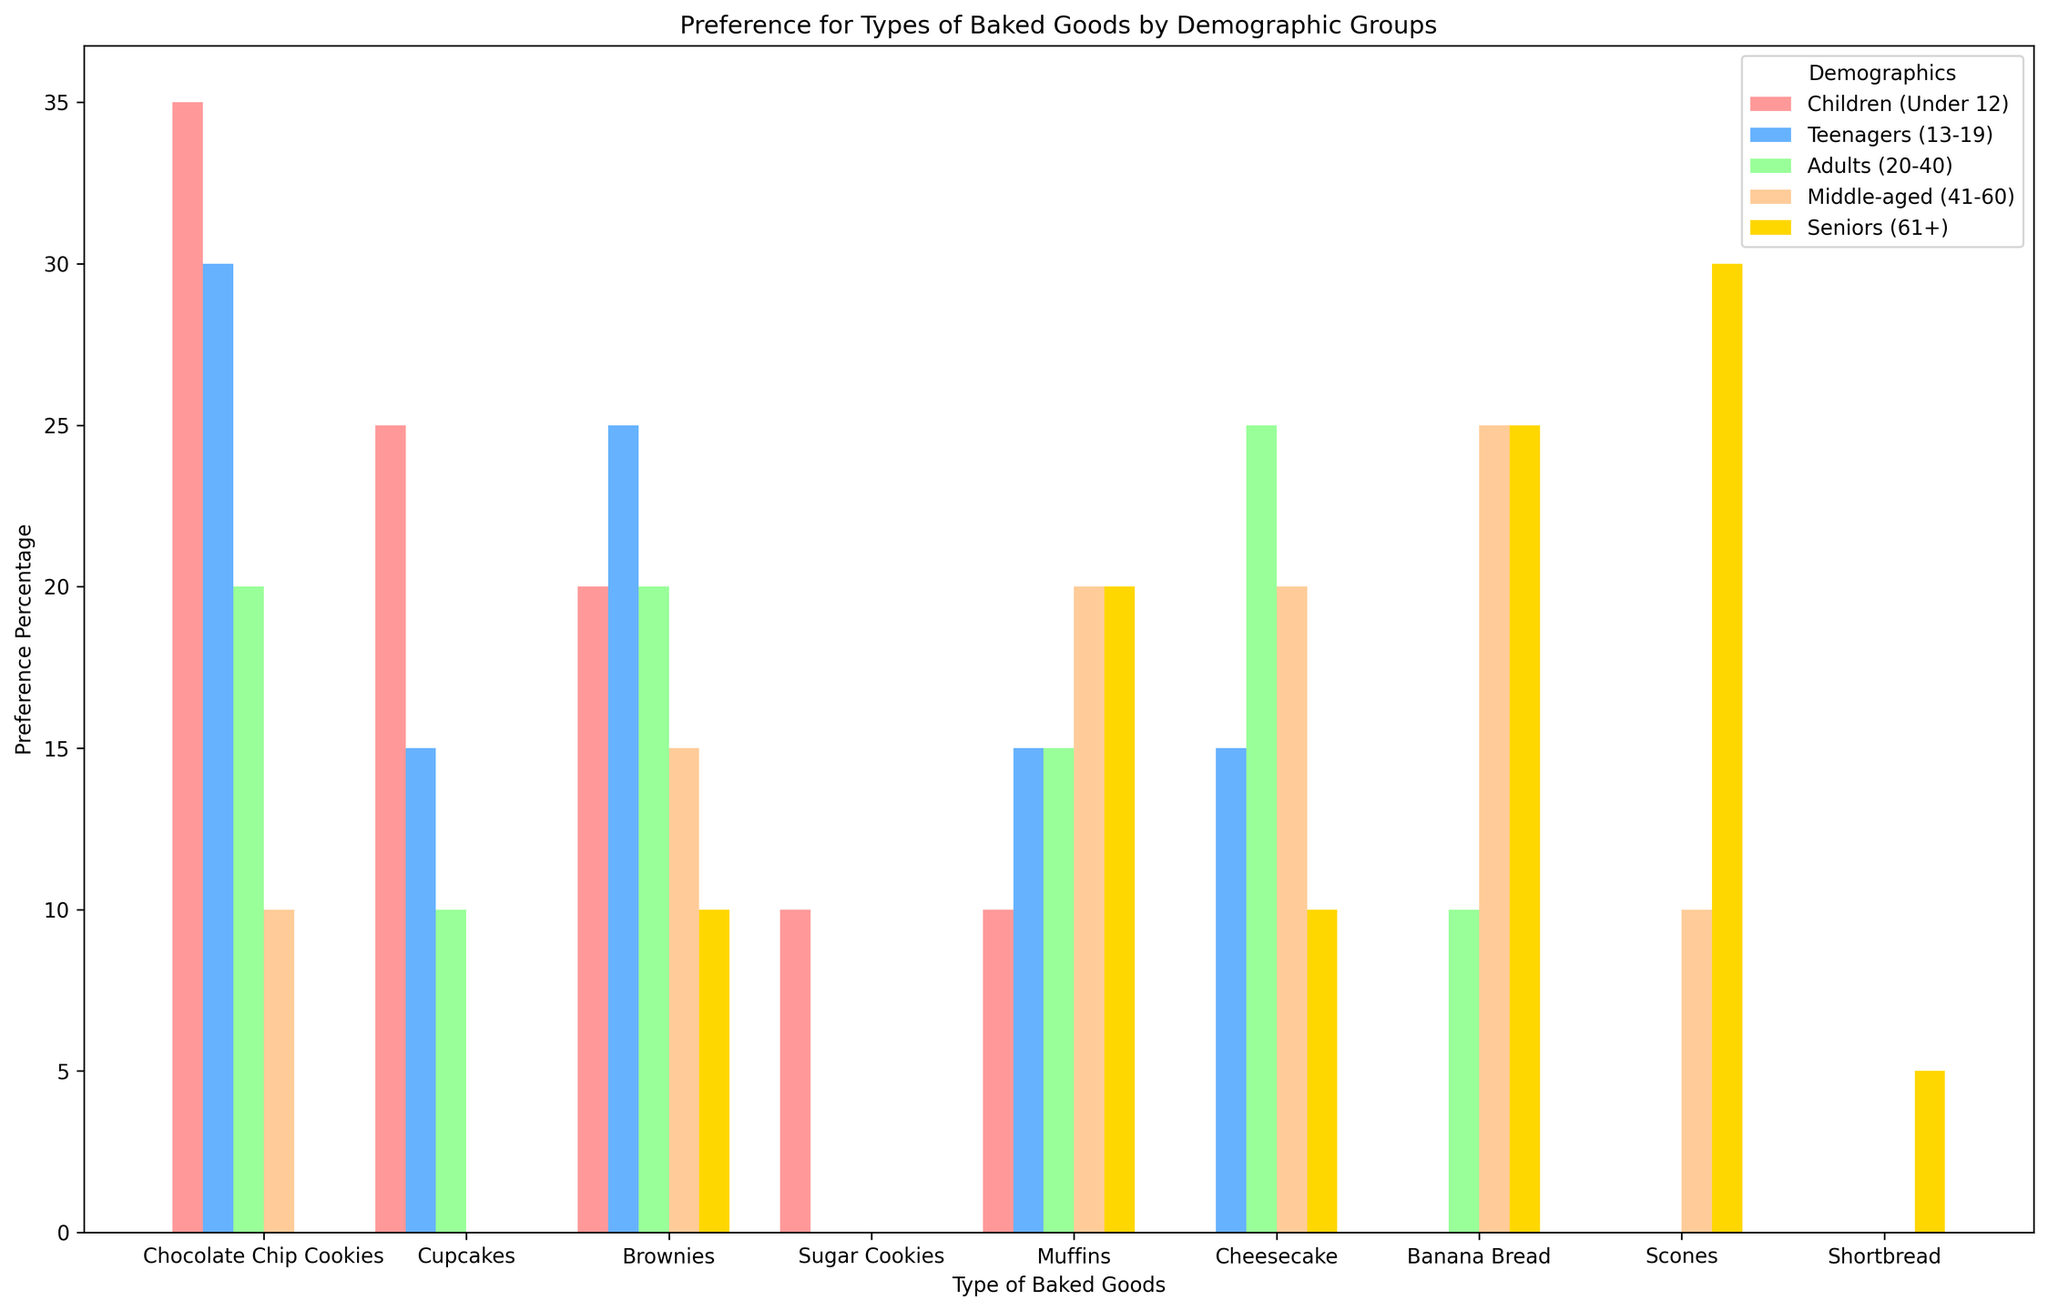What's the most preferred baked good among children? Look at the bar heights for the "Children (Under 12)" category. The tallest bar represents "Chocolate Chip Cookies" with a 35% preference.
Answer: Chocolate Chip Cookies Which demographic group prefers cupcakes the most? Look at the bars for "Cupcakes" across different demographic groups. The highest bar is in the "Children (Under 12)" category at 25%.
Answer: Children (Under 12) Which group shows the highest preference for cheesecake? Examine the bars for "Cheesecake" in different demographics. The highest bar is in the "Adults (20-40)" category at 25%.
Answer: Adults (20-40) How do the preferences for chocolate chip cookies compare between children and teenagers? Compare the heights of the "Chocolate Chip Cookies" bars for "Children (Under 12)" and "Teenagers (13-19)". The children prefer it more (35%) compared to teenagers (30%).
Answer: Children prefer it more Which baked good has the least preference among all demographic groups? Identify the shortest bar in all categories. "Shortbread" among "Seniors (61+)" is the lowest with a 5% preference.
Answer: Shortbread What is the total preference percentage for muffins among all demographic groups? Sum the preference percentages for "Muffins" from all groups: 10% (Children) + 15% (Teenagers) + 15% (Adults) + 20% (Middle-aged) + 20% (Seniors) = 80%.
Answer: 80% Is there any baked good preferred equally by two different demographic groups? Find bars with the same height for any baked good across different demographics. "Cheesecake" is preferred equally by "Teenagers (13-19)" and "Seniors (61+)" at 15%.
Answer: Cheesecake by Teenagers and Seniors What percentage of middle-aged adults prefer scones? Look at the bar height for "Scones" under "Middle-aged (41-60)". It shows a 10% preference.
Answer: 10% What's the combined preference for brownies by children and adults? Sum the percentages for "Brownies" in "Children (Under 12)" and "Adults (20-40)": 20% + 20% = 40%.
Answer: 40% Which demographic group prefers banana bread the most? Look at the bars for "Banana Bread" across different demographics. The highest bar is in the "Middle-aged (41-60)" category at 25%.
Answer: Middle-aged (41-60) 